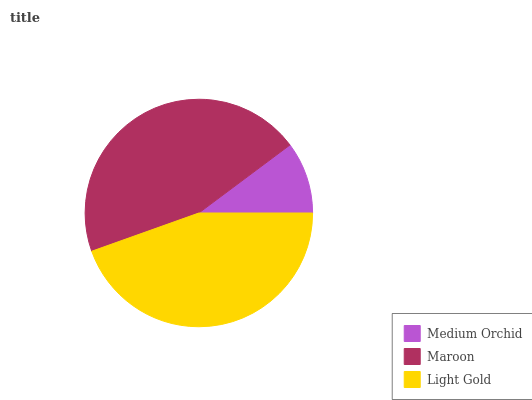Is Medium Orchid the minimum?
Answer yes or no. Yes. Is Maroon the maximum?
Answer yes or no. Yes. Is Light Gold the minimum?
Answer yes or no. No. Is Light Gold the maximum?
Answer yes or no. No. Is Maroon greater than Light Gold?
Answer yes or no. Yes. Is Light Gold less than Maroon?
Answer yes or no. Yes. Is Light Gold greater than Maroon?
Answer yes or no. No. Is Maroon less than Light Gold?
Answer yes or no. No. Is Light Gold the high median?
Answer yes or no. Yes. Is Light Gold the low median?
Answer yes or no. Yes. Is Medium Orchid the high median?
Answer yes or no. No. Is Medium Orchid the low median?
Answer yes or no. No. 